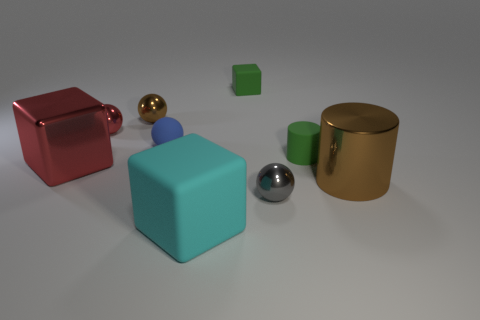The brown metallic object on the left side of the brown object that is to the right of the cylinder that is on the left side of the brown cylinder is what shape? sphere 